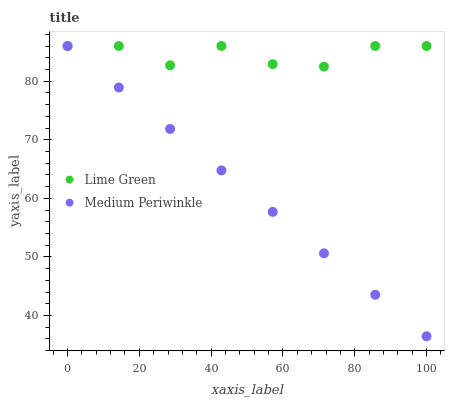Does Medium Periwinkle have the minimum area under the curve?
Answer yes or no. Yes. Does Lime Green have the maximum area under the curve?
Answer yes or no. Yes. Does Lime Green have the minimum area under the curve?
Answer yes or no. No. Is Medium Periwinkle the smoothest?
Answer yes or no. Yes. Is Lime Green the roughest?
Answer yes or no. Yes. Is Lime Green the smoothest?
Answer yes or no. No. Does Medium Periwinkle have the lowest value?
Answer yes or no. Yes. Does Lime Green have the lowest value?
Answer yes or no. No. Does Lime Green have the highest value?
Answer yes or no. Yes. Does Medium Periwinkle intersect Lime Green?
Answer yes or no. Yes. Is Medium Periwinkle less than Lime Green?
Answer yes or no. No. Is Medium Periwinkle greater than Lime Green?
Answer yes or no. No. 